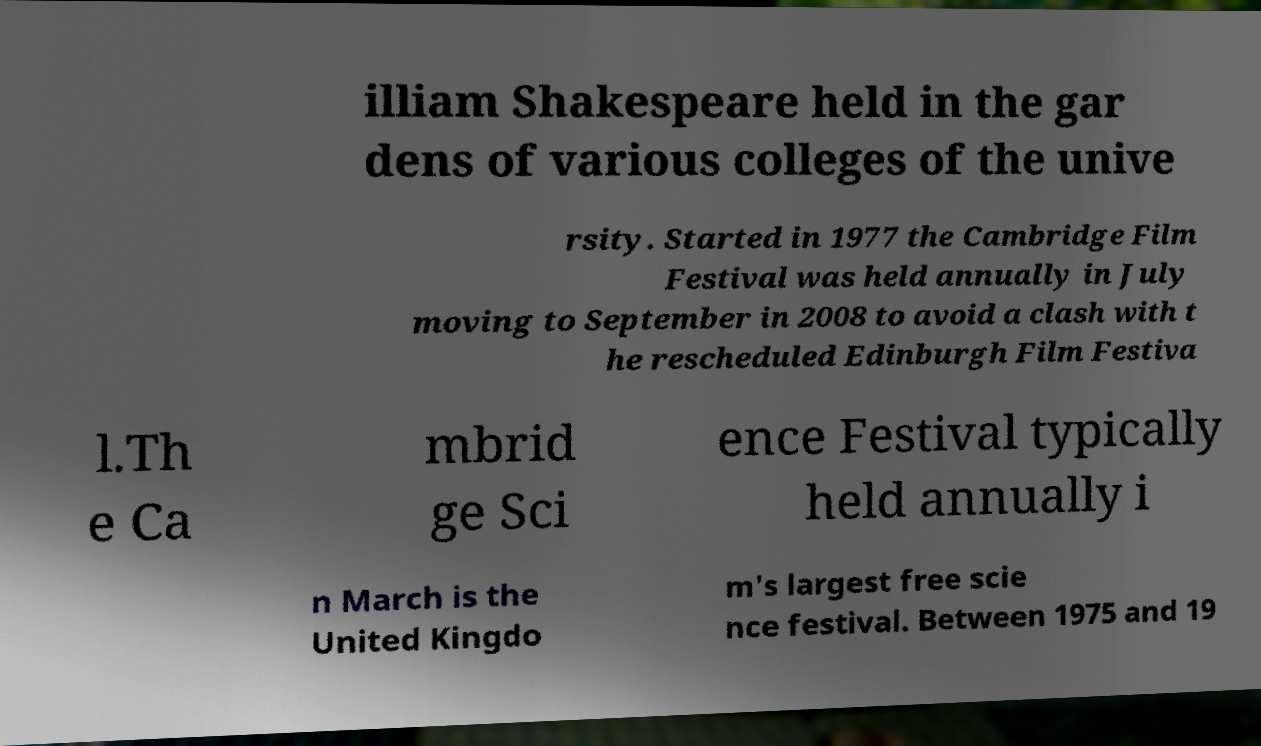What messages or text are displayed in this image? I need them in a readable, typed format. illiam Shakespeare held in the gar dens of various colleges of the unive rsity. Started in 1977 the Cambridge Film Festival was held annually in July moving to September in 2008 to avoid a clash with t he rescheduled Edinburgh Film Festiva l.Th e Ca mbrid ge Sci ence Festival typically held annually i n March is the United Kingdo m's largest free scie nce festival. Between 1975 and 19 